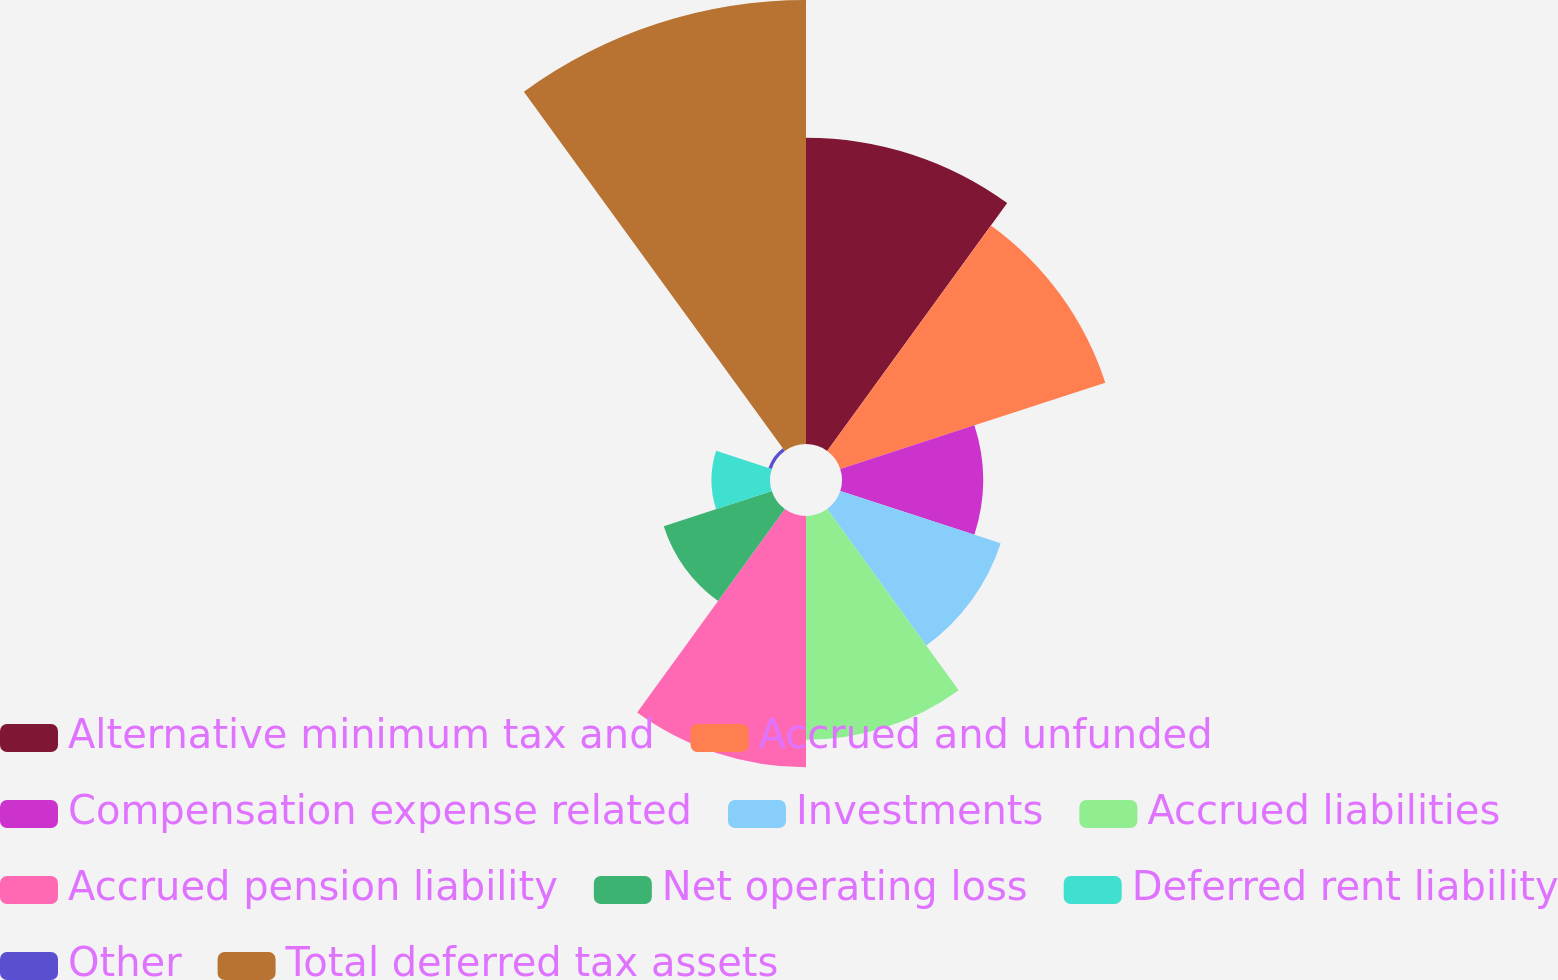Convert chart. <chart><loc_0><loc_0><loc_500><loc_500><pie_chart><fcel>Alternative minimum tax and<fcel>Accrued and unfunded<fcel>Compensation expense related<fcel>Investments<fcel>Accrued liabilities<fcel>Accrued pension liability<fcel>Net operating loss<fcel>Deferred rent liability<fcel>Other<fcel>Total deferred tax assets<nl><fcel>15.4%<fcel>14.01%<fcel>7.09%<fcel>8.48%<fcel>11.25%<fcel>12.63%<fcel>5.71%<fcel>2.94%<fcel>0.17%<fcel>22.32%<nl></chart> 